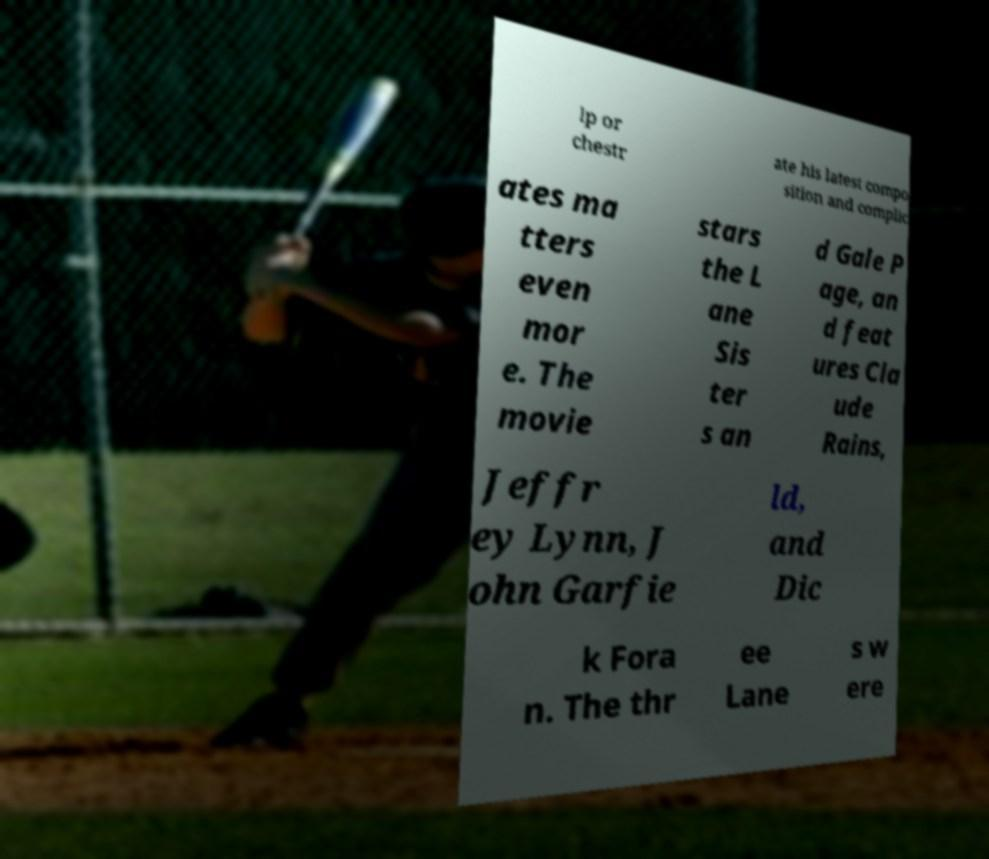Could you assist in decoding the text presented in this image and type it out clearly? lp or chestr ate his latest compo sition and complic ates ma tters even mor e. The movie stars the L ane Sis ter s an d Gale P age, an d feat ures Cla ude Rains, Jeffr ey Lynn, J ohn Garfie ld, and Dic k Fora n. The thr ee Lane s w ere 